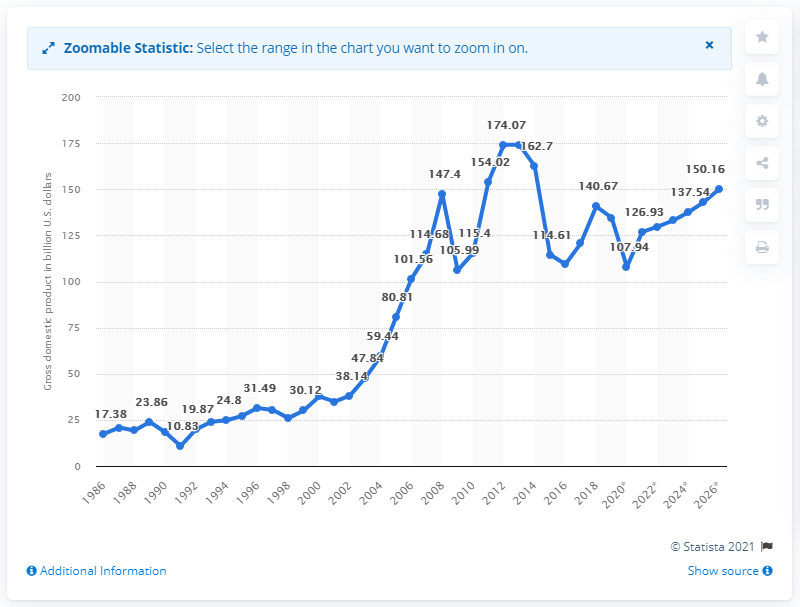Mention a couple of crucial points in this snapshot. In 2019, the Gross Domestic Product (GDP) of Kuwait was 134.62. 